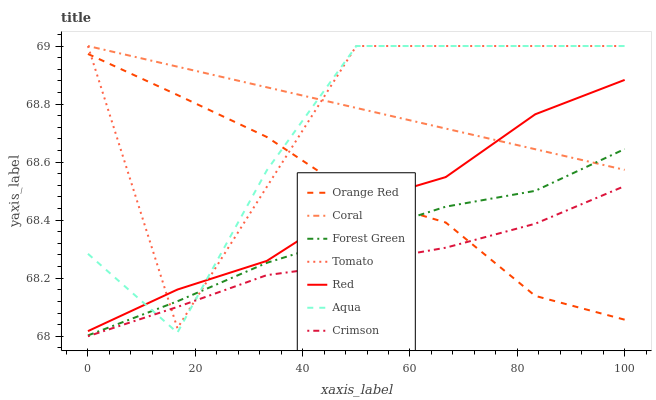Does Crimson have the minimum area under the curve?
Answer yes or no. Yes. Does Coral have the maximum area under the curve?
Answer yes or no. Yes. Does Aqua have the minimum area under the curve?
Answer yes or no. No. Does Aqua have the maximum area under the curve?
Answer yes or no. No. Is Coral the smoothest?
Answer yes or no. Yes. Is Tomato the roughest?
Answer yes or no. Yes. Is Aqua the smoothest?
Answer yes or no. No. Is Aqua the roughest?
Answer yes or no. No. Does Crimson have the lowest value?
Answer yes or no. Yes. Does Aqua have the lowest value?
Answer yes or no. No. Does Aqua have the highest value?
Answer yes or no. Yes. Does Forest Green have the highest value?
Answer yes or no. No. Is Crimson less than Red?
Answer yes or no. Yes. Is Forest Green greater than Crimson?
Answer yes or no. Yes. Does Coral intersect Red?
Answer yes or no. Yes. Is Coral less than Red?
Answer yes or no. No. Is Coral greater than Red?
Answer yes or no. No. Does Crimson intersect Red?
Answer yes or no. No. 